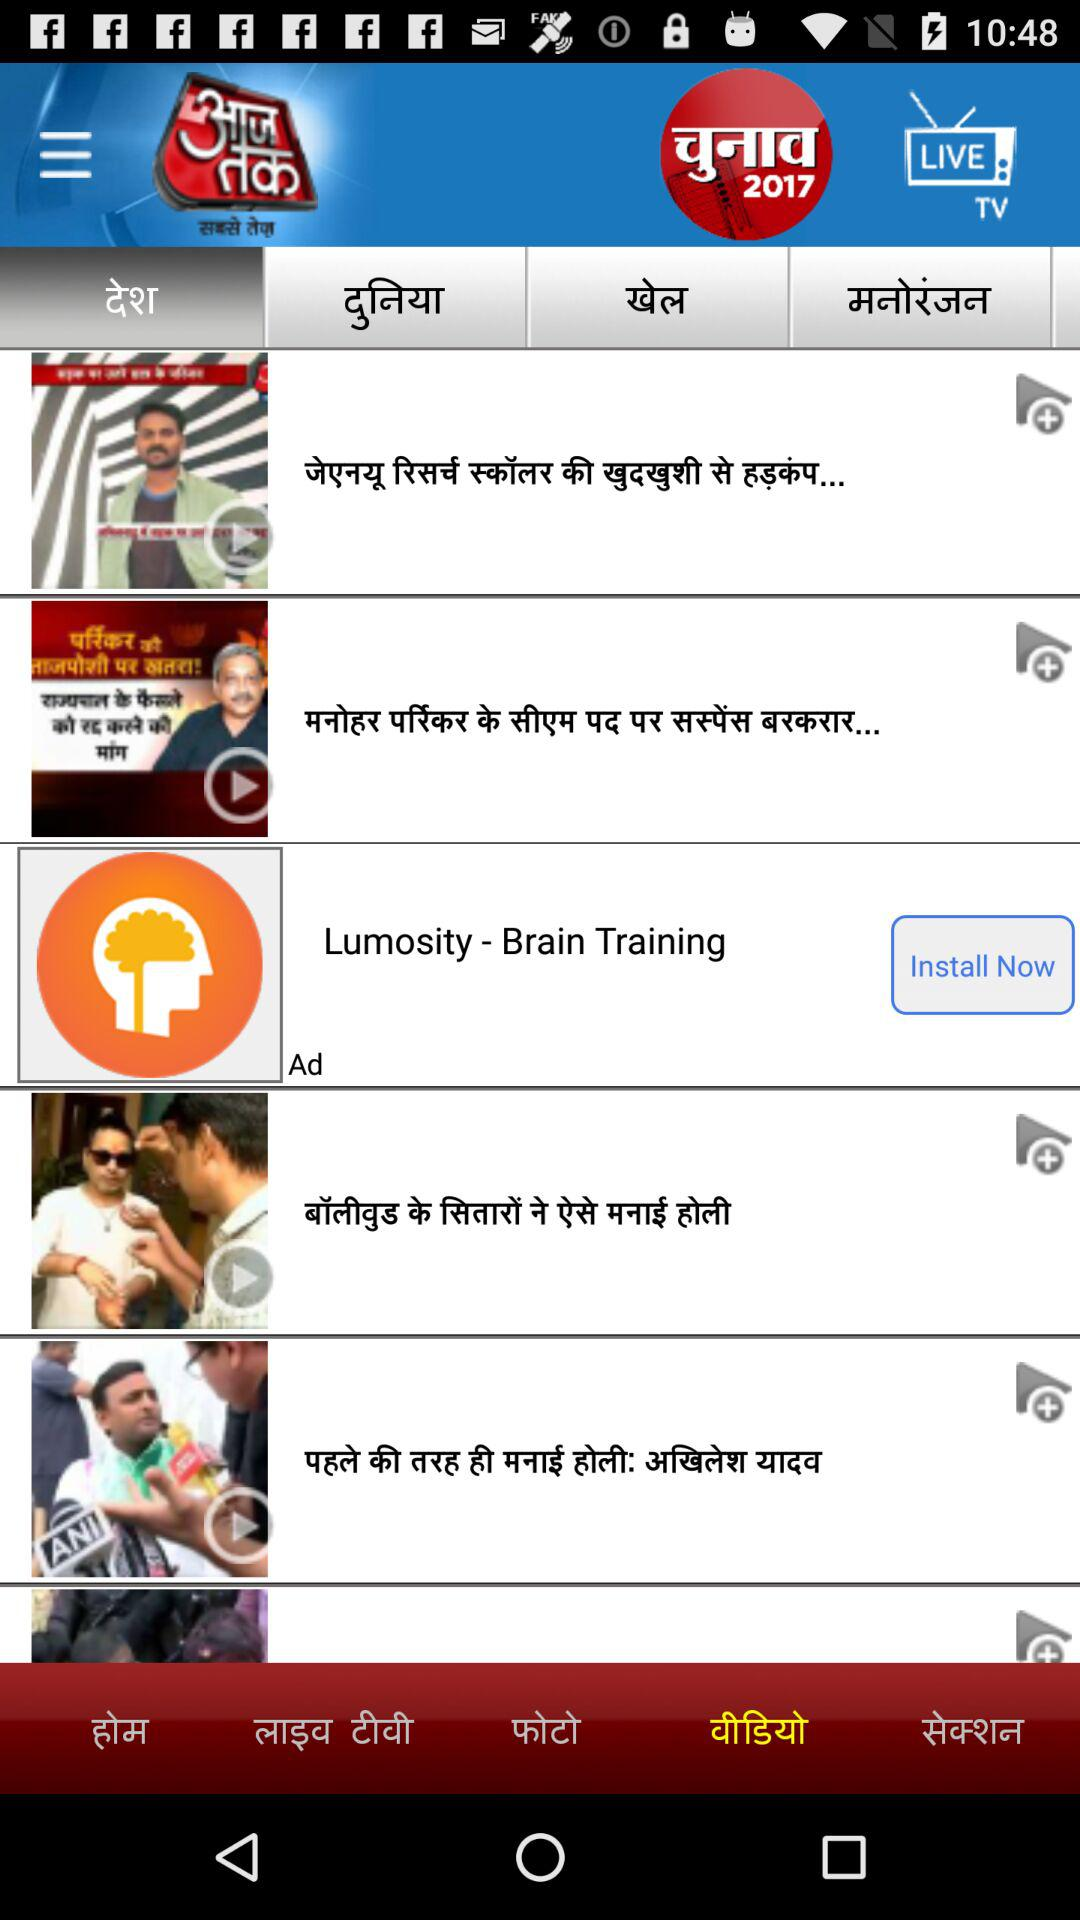Which tab is selected?
When the provided information is insufficient, respond with <no answer>. <no answer> 